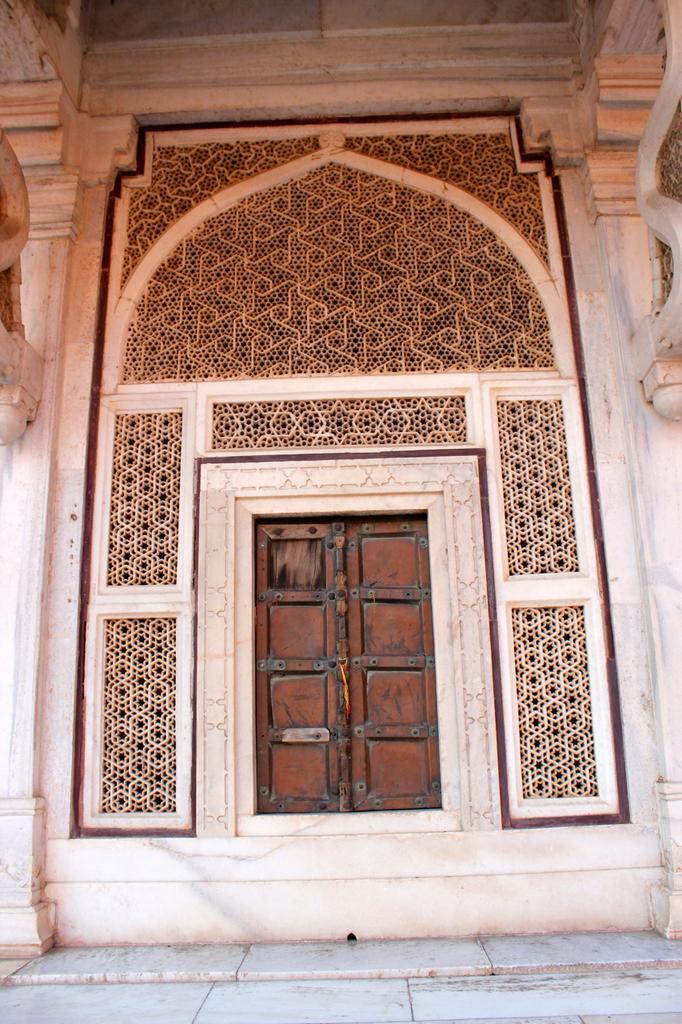In one or two sentences, can you explain what this image depicts? In the center of the image there is a building,wall,wooden door,pillars and a few other objects. And we can see some design on the wall. 